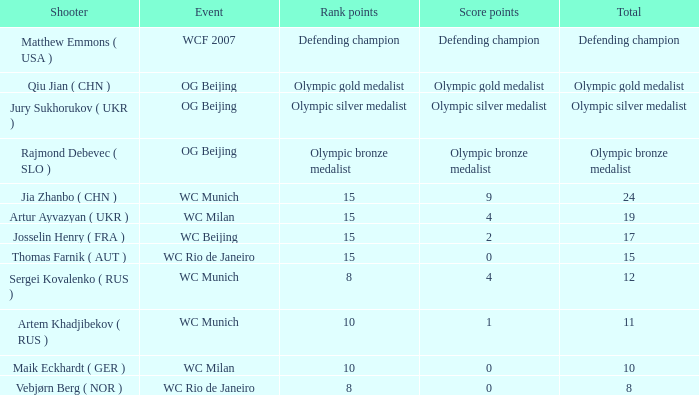With a sum of 11, what are the score points? 1.0. 